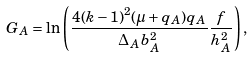<formula> <loc_0><loc_0><loc_500><loc_500>G _ { A } = \ln \left ( \frac { 4 ( k - 1 ) ^ { 2 } ( \mu + q _ { A } ) q _ { A } } { \Delta _ { A } b _ { A } ^ { 2 } } \frac { f } { h _ { A } ^ { 2 } } \right ) ,</formula> 